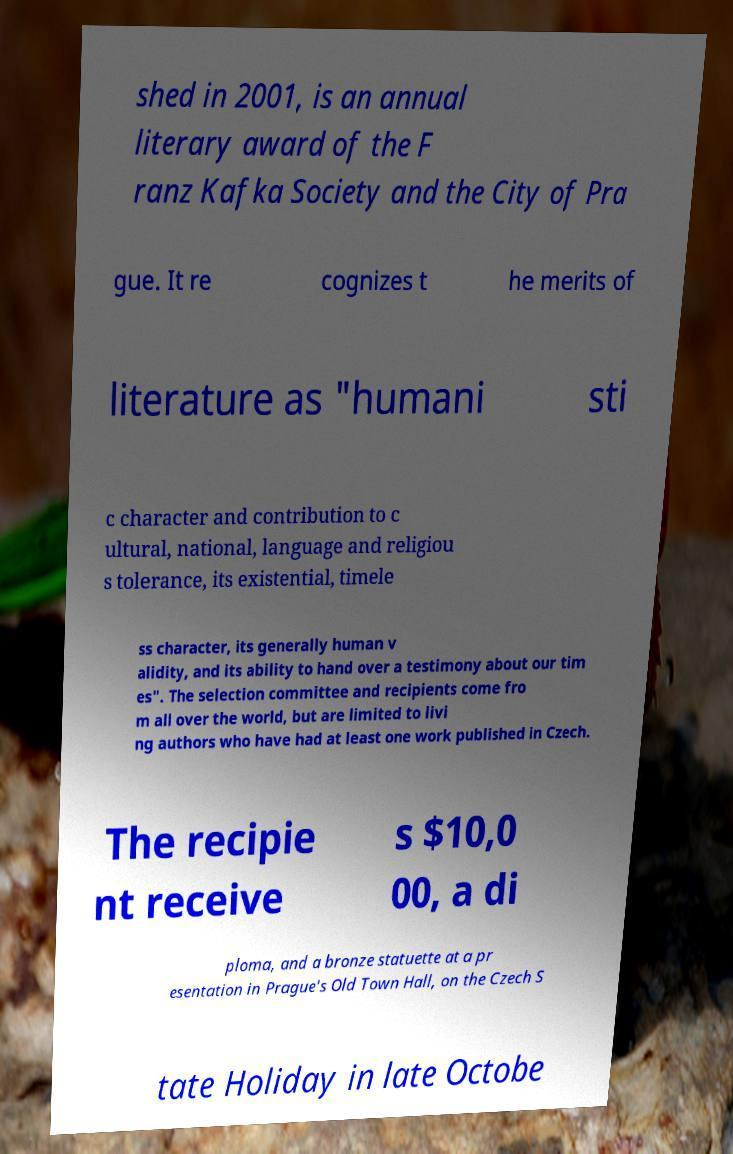Can you read and provide the text displayed in the image?This photo seems to have some interesting text. Can you extract and type it out for me? shed in 2001, is an annual literary award of the F ranz Kafka Society and the City of Pra gue. It re cognizes t he merits of literature as "humani sti c character and contribution to c ultural, national, language and religiou s tolerance, its existential, timele ss character, its generally human v alidity, and its ability to hand over a testimony about our tim es". The selection committee and recipients come fro m all over the world, but are limited to livi ng authors who have had at least one work published in Czech. The recipie nt receive s $10,0 00, a di ploma, and a bronze statuette at a pr esentation in Prague's Old Town Hall, on the Czech S tate Holiday in late Octobe 